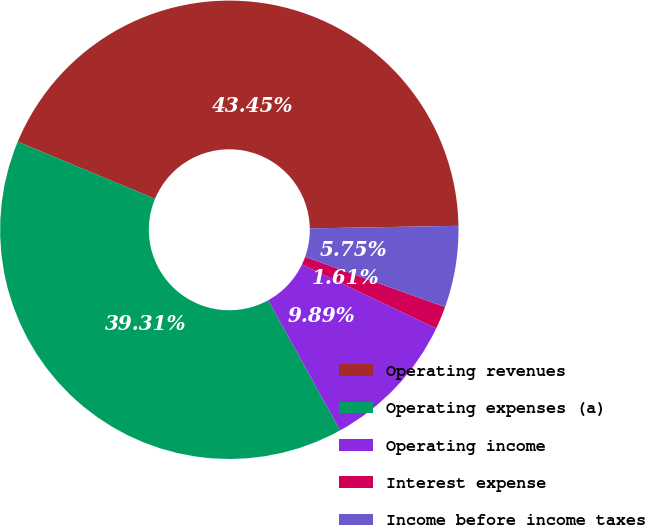Convert chart to OTSL. <chart><loc_0><loc_0><loc_500><loc_500><pie_chart><fcel>Operating revenues<fcel>Operating expenses (a)<fcel>Operating income<fcel>Interest expense<fcel>Income before income taxes<nl><fcel>43.45%<fcel>39.31%<fcel>9.89%<fcel>1.61%<fcel>5.75%<nl></chart> 